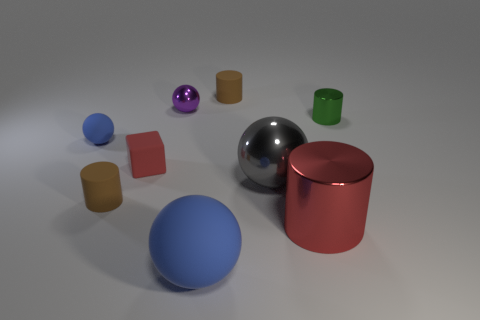There is a metal object in front of the small rubber cylinder that is on the left side of the brown cylinder that is behind the small blue matte object; what shape is it?
Provide a short and direct response. Cylinder. Are there any big red blocks made of the same material as the large blue ball?
Give a very brief answer. No. Does the metallic ball that is behind the tiny red rubber block have the same color as the object that is in front of the red cylinder?
Offer a terse response. No. Is the number of small blue balls that are in front of the red cylinder less than the number of gray shiny things?
Give a very brief answer. Yes. What number of objects are tiny metallic cylinders or tiny brown cylinders on the left side of the red matte object?
Provide a short and direct response. 2. The big object that is the same material as the small red cube is what color?
Your response must be concise. Blue. How many objects are either tiny red shiny spheres or cubes?
Provide a short and direct response. 1. The rubber sphere that is the same size as the red rubber object is what color?
Ensure brevity in your answer.  Blue. How many objects are either small brown objects that are on the left side of the large blue sphere or large rubber spheres?
Provide a short and direct response. 2. What number of other objects are the same size as the red shiny cylinder?
Make the answer very short. 2. 